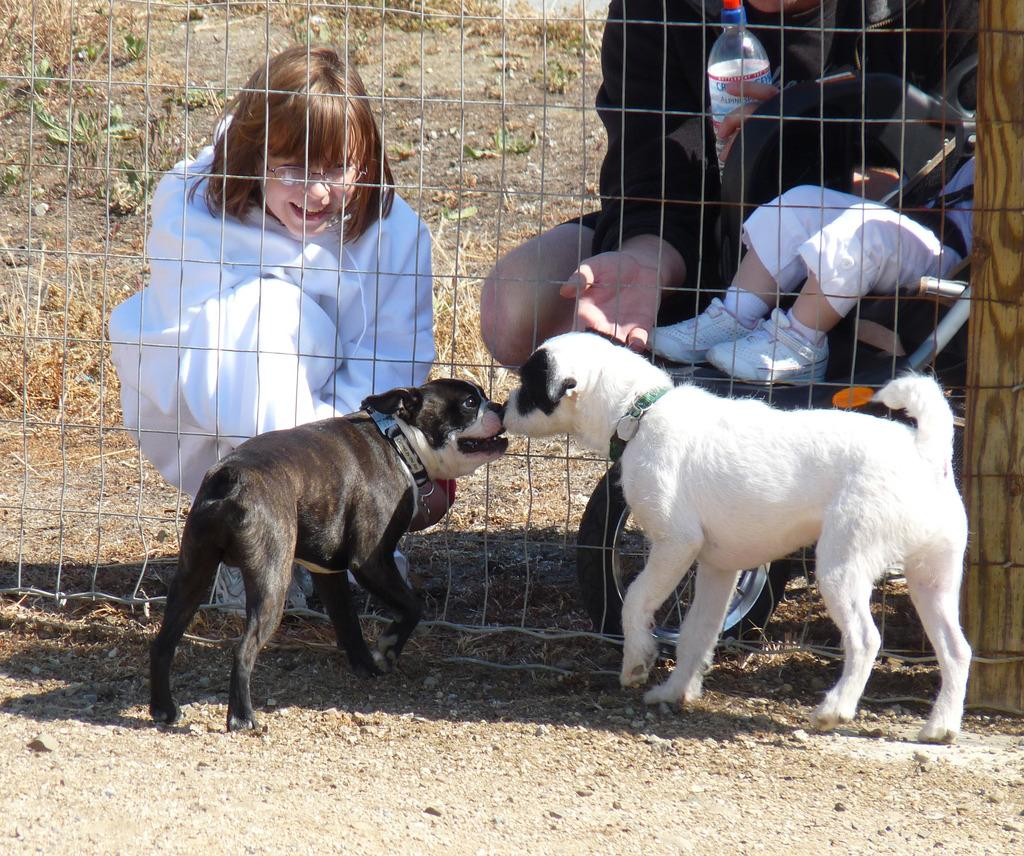How many dogs are present in the image? There are two dogs in the image. Who else is present in the image besides the dogs? There are two people and a child in the image. What can be seen in the background of the image? There is a fence in the image. What type of noise is the grape making in the image? There is no grape present in the image, so it cannot make any noise. 